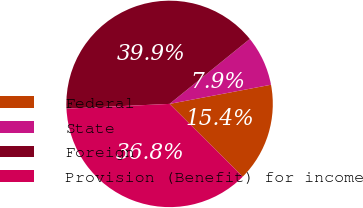<chart> <loc_0><loc_0><loc_500><loc_500><pie_chart><fcel>Federal<fcel>State<fcel>Foreign<fcel>Provision (Benefit) for income<nl><fcel>15.44%<fcel>7.86%<fcel>39.9%<fcel>36.8%<nl></chart> 